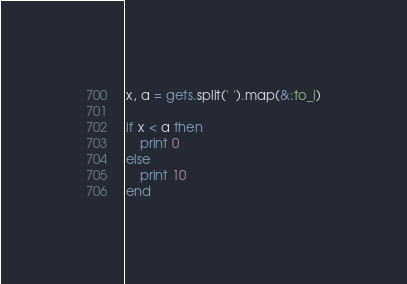Convert code to text. <code><loc_0><loc_0><loc_500><loc_500><_Ruby_>x, a = gets.split(' ').map(&:to_i)

if x < a then
    print 0
else
    print 10
end</code> 